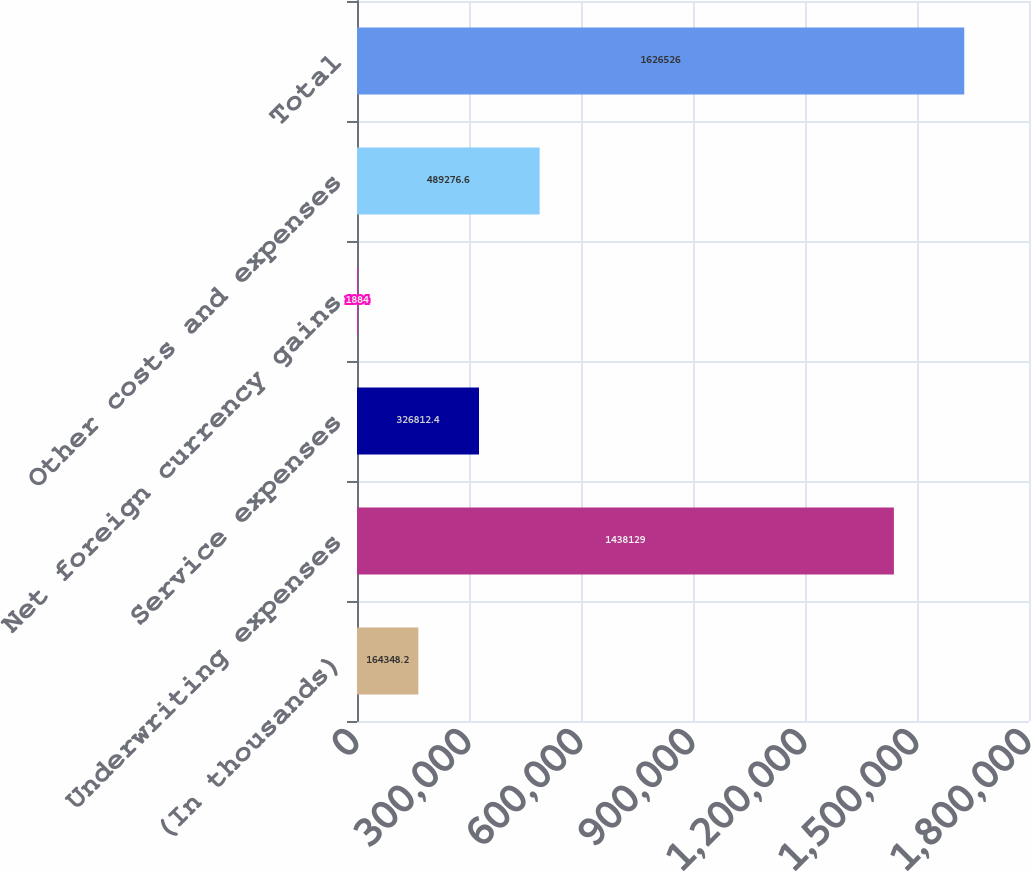<chart> <loc_0><loc_0><loc_500><loc_500><bar_chart><fcel>(In thousands)<fcel>Underwriting expenses<fcel>Service expenses<fcel>Net foreign currency gains<fcel>Other costs and expenses<fcel>Total<nl><fcel>164348<fcel>1.43813e+06<fcel>326812<fcel>1884<fcel>489277<fcel>1.62653e+06<nl></chart> 